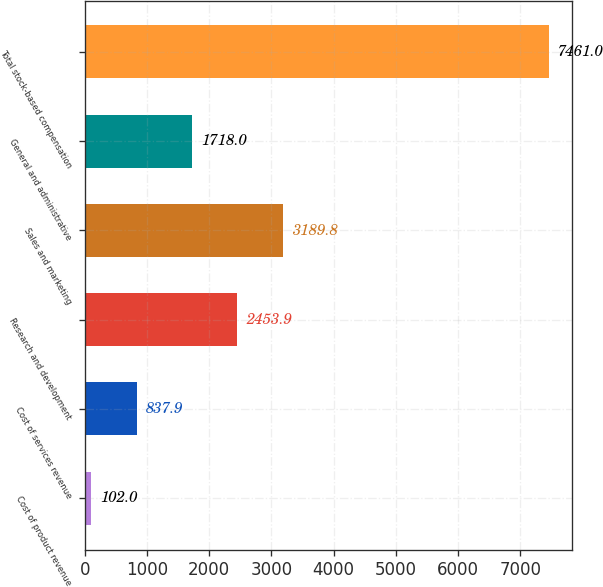Convert chart to OTSL. <chart><loc_0><loc_0><loc_500><loc_500><bar_chart><fcel>Cost of product revenue<fcel>Cost of services revenue<fcel>Research and development<fcel>Sales and marketing<fcel>General and administrative<fcel>Total stock-based compensation<nl><fcel>102<fcel>837.9<fcel>2453.9<fcel>3189.8<fcel>1718<fcel>7461<nl></chart> 